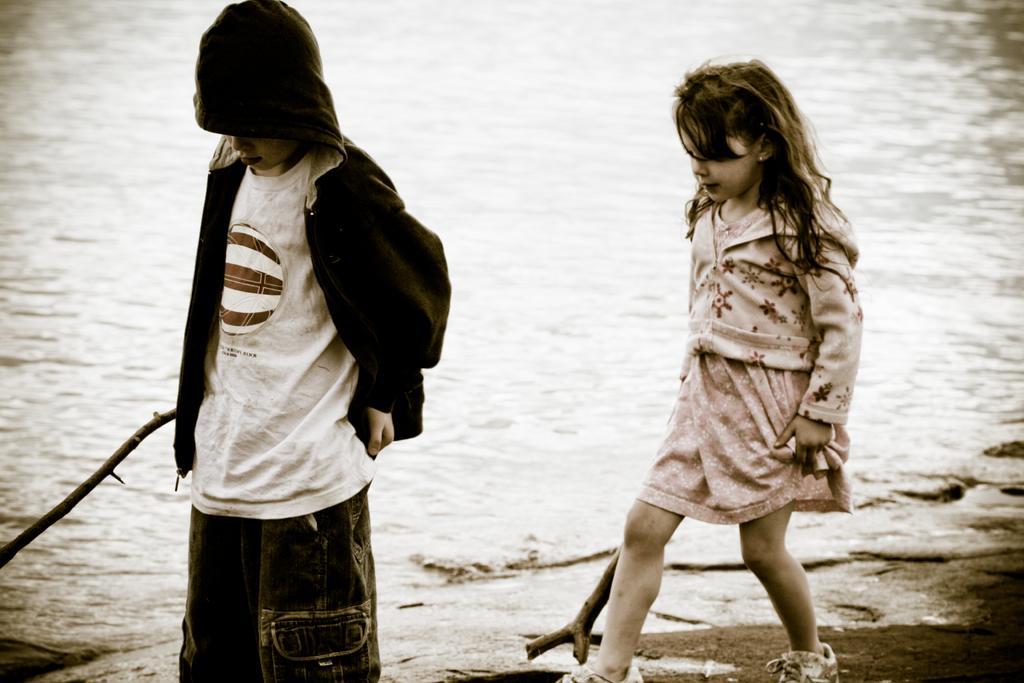Can you describe this image briefly? In this image in front there are two people holding wooden sticks. Behind them there is water. 